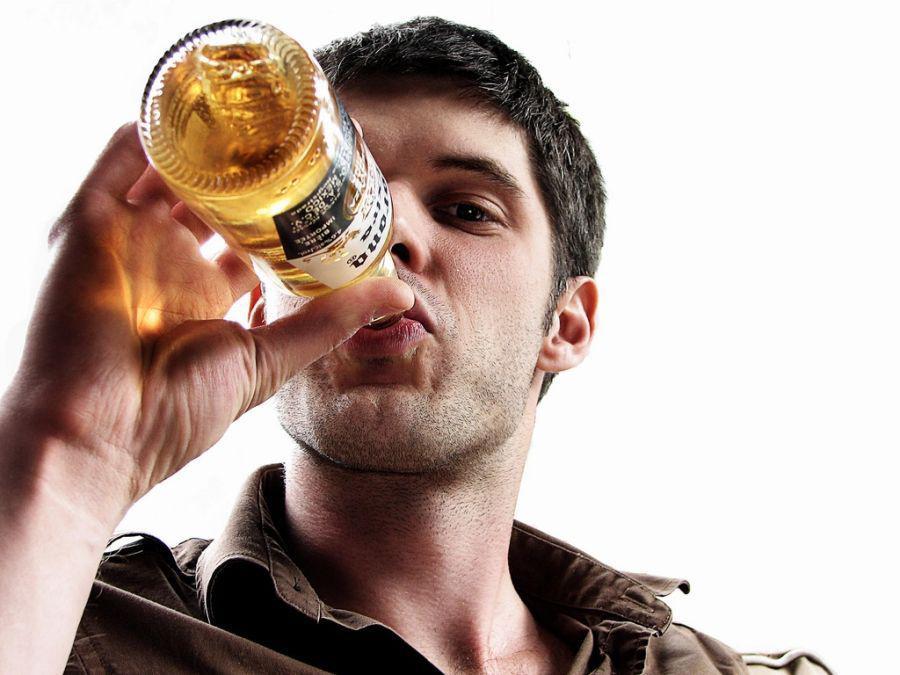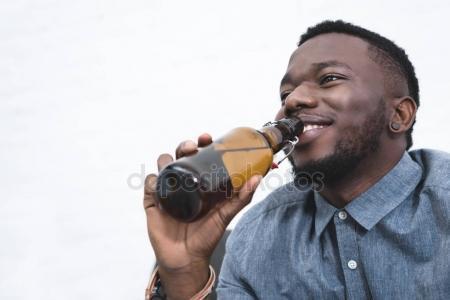The first image is the image on the left, the second image is the image on the right. Given the left and right images, does the statement "A man is holding a bottle to his mouth." hold true? Answer yes or no. Yes. The first image is the image on the left, the second image is the image on the right. Analyze the images presented: Is the assertion "There are a total of nine people." valid? Answer yes or no. No. 